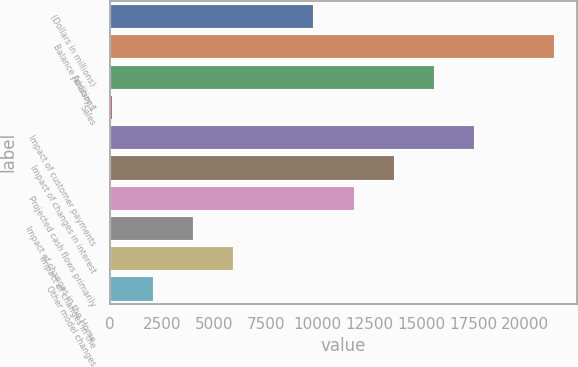Convert chart. <chart><loc_0><loc_0><loc_500><loc_500><bar_chart><fcel>(Dollars in millions)<fcel>Balance January 1<fcel>Additions<fcel>Sales<fcel>Impact of customer payments<fcel>Impact of changes in interest<fcel>Projected cash flows primarily<fcel>Impact of changes in the Home<fcel>Impact of changes in the<fcel>Other model changes<nl><fcel>9787.5<fcel>21400.5<fcel>15594<fcel>110<fcel>17529.5<fcel>13658.5<fcel>11723<fcel>3981<fcel>5916.5<fcel>2045.5<nl></chart> 